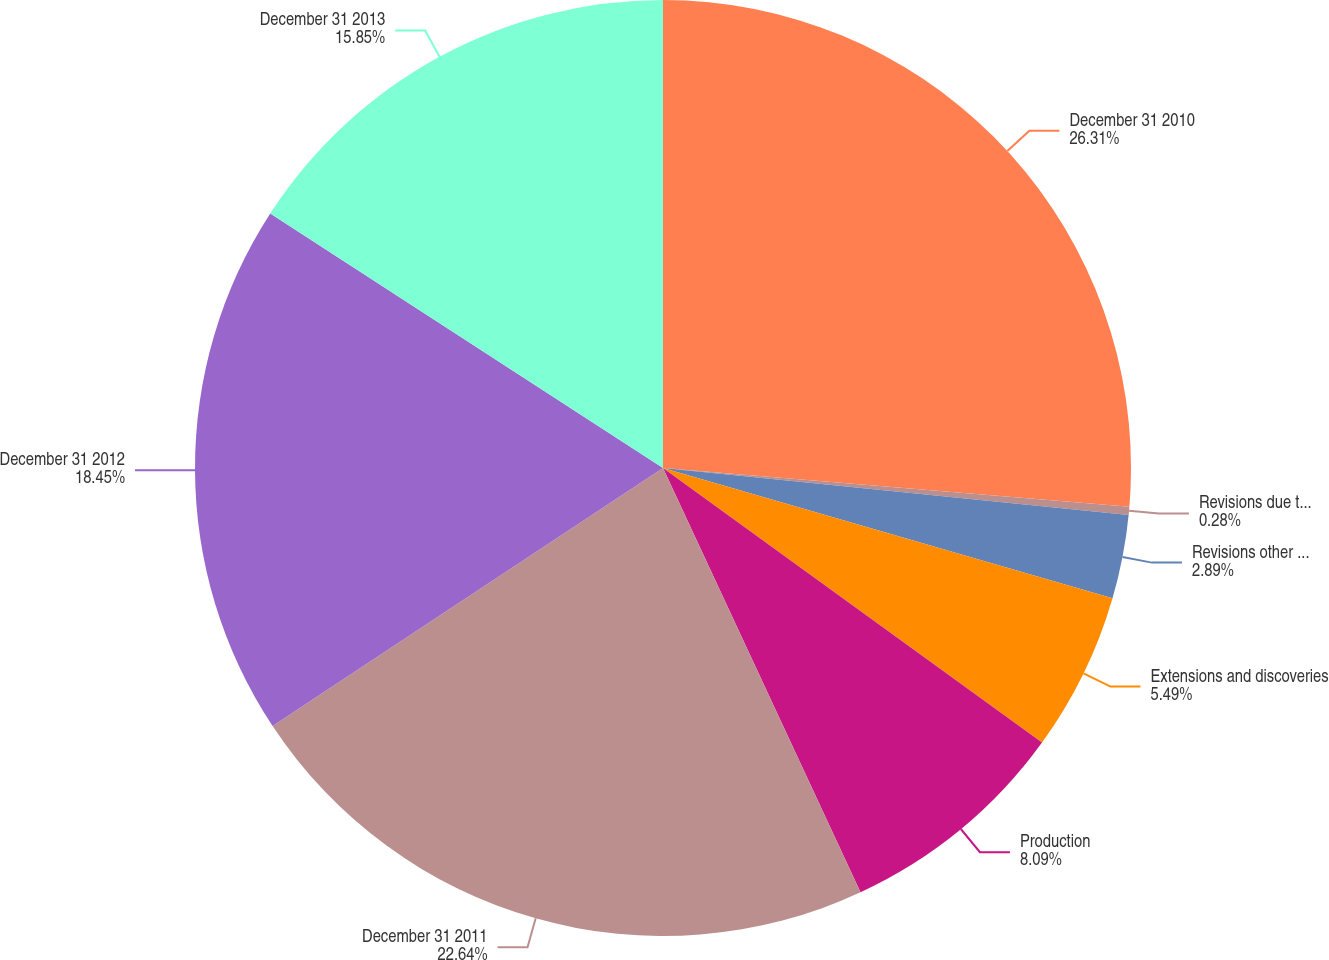Convert chart. <chart><loc_0><loc_0><loc_500><loc_500><pie_chart><fcel>December 31 2010<fcel>Revisions due to prices<fcel>Revisions other than price<fcel>Extensions and discoveries<fcel>Production<fcel>December 31 2011<fcel>December 31 2012<fcel>December 31 2013<nl><fcel>26.32%<fcel>0.28%<fcel>2.89%<fcel>5.49%<fcel>8.09%<fcel>22.64%<fcel>18.45%<fcel>15.85%<nl></chart> 